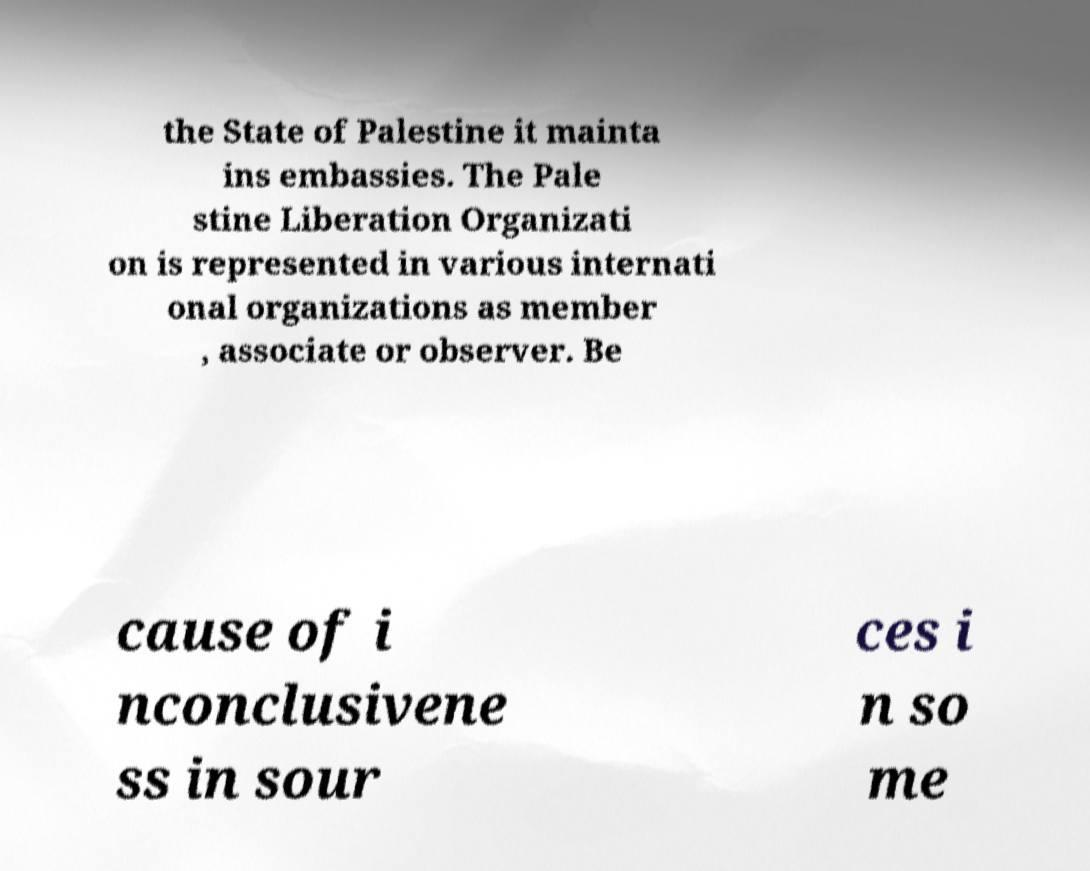There's text embedded in this image that I need extracted. Can you transcribe it verbatim? the State of Palestine it mainta ins embassies. The Pale stine Liberation Organizati on is represented in various internati onal organizations as member , associate or observer. Be cause of i nconclusivene ss in sour ces i n so me 